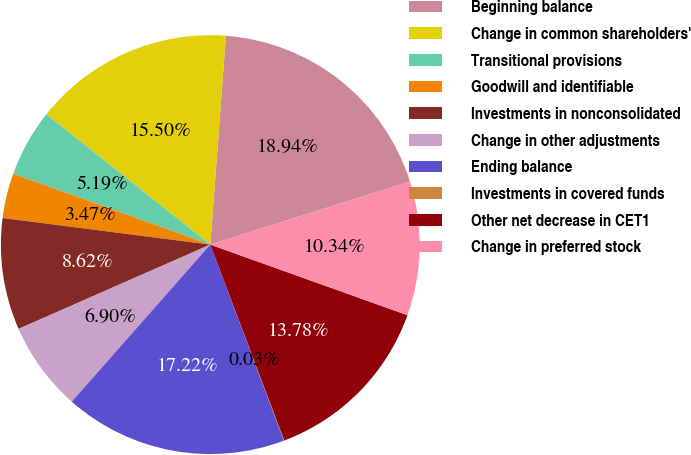Convert chart to OTSL. <chart><loc_0><loc_0><loc_500><loc_500><pie_chart><fcel>Beginning balance<fcel>Change in common shareholders'<fcel>Transitional provisions<fcel>Goodwill and identifiable<fcel>Investments in nonconsolidated<fcel>Change in other adjustments<fcel>Ending balance<fcel>Investments in covered funds<fcel>Other net decrease in CET1<fcel>Change in preferred stock<nl><fcel>18.94%<fcel>15.5%<fcel>5.19%<fcel>3.47%<fcel>8.62%<fcel>6.9%<fcel>17.22%<fcel>0.03%<fcel>13.78%<fcel>10.34%<nl></chart> 